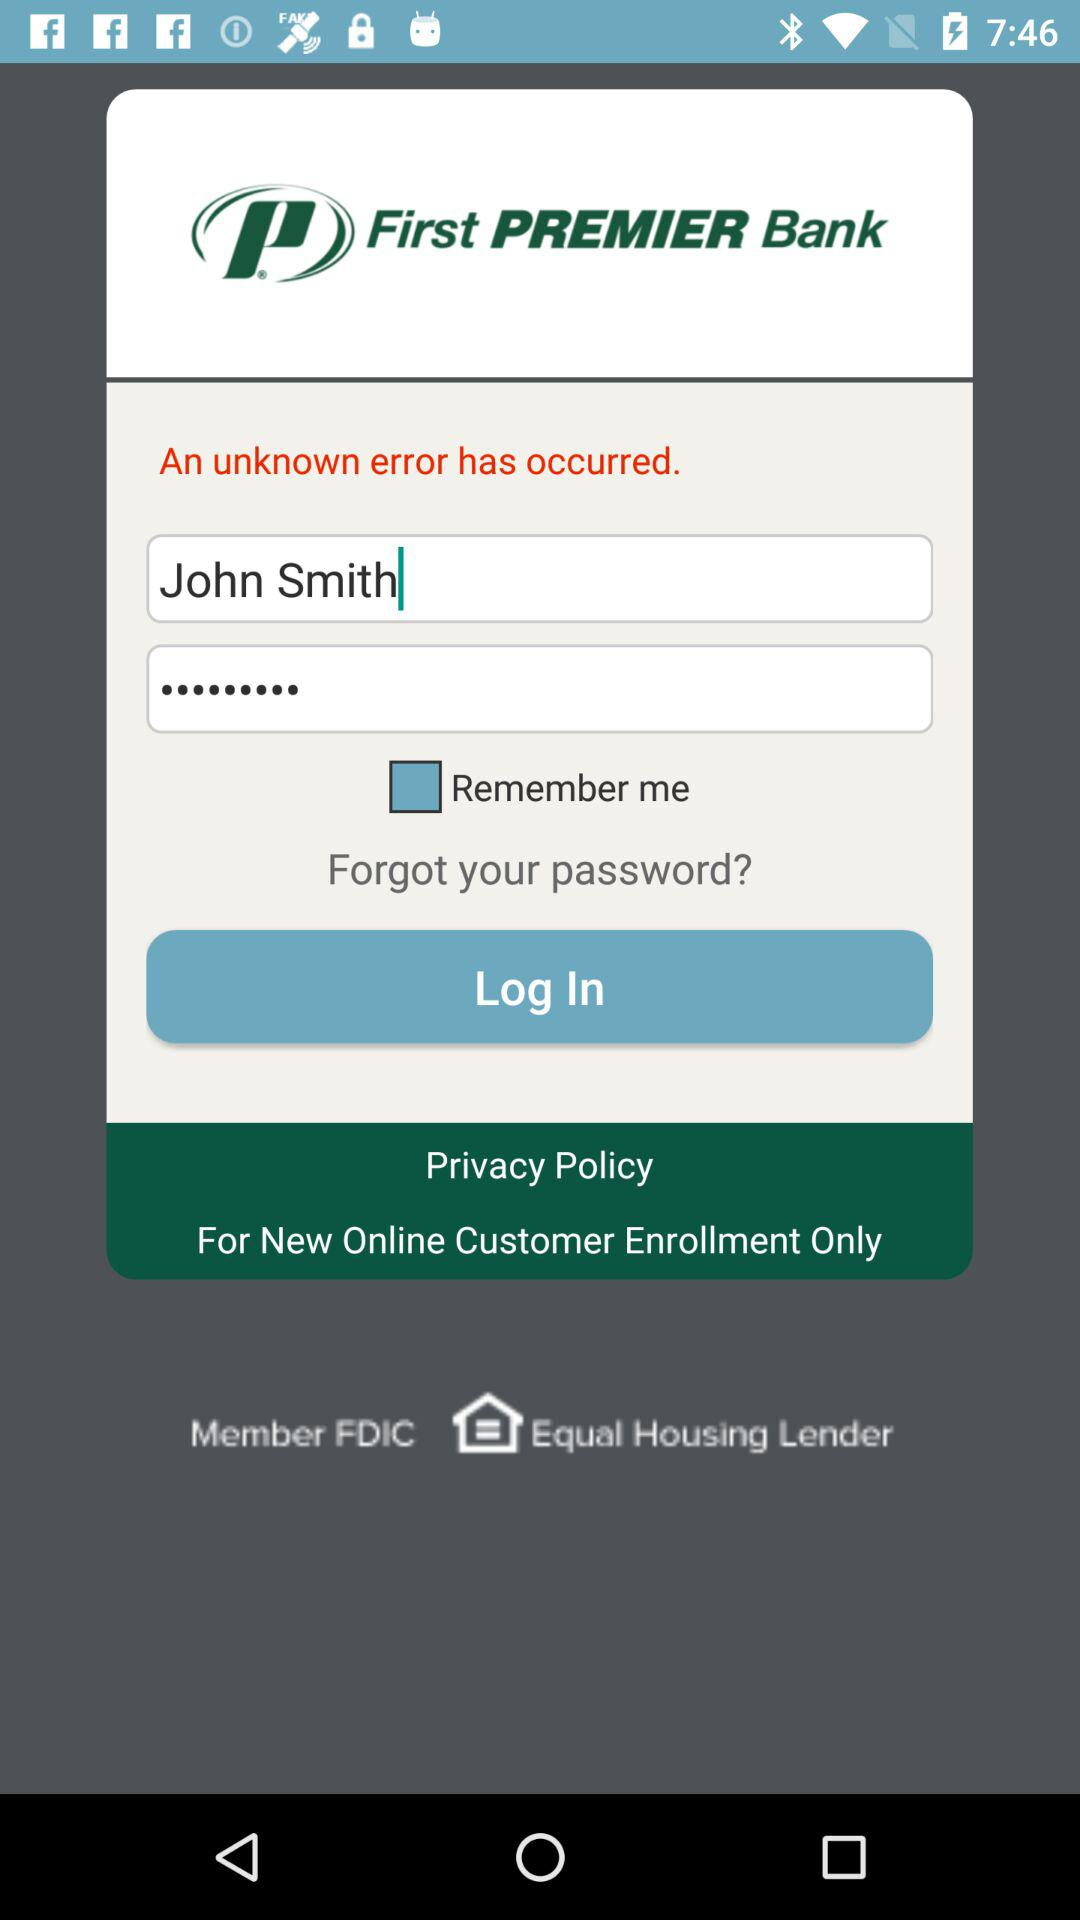How many text input fields are there on this screen?
Answer the question using a single word or phrase. 2 